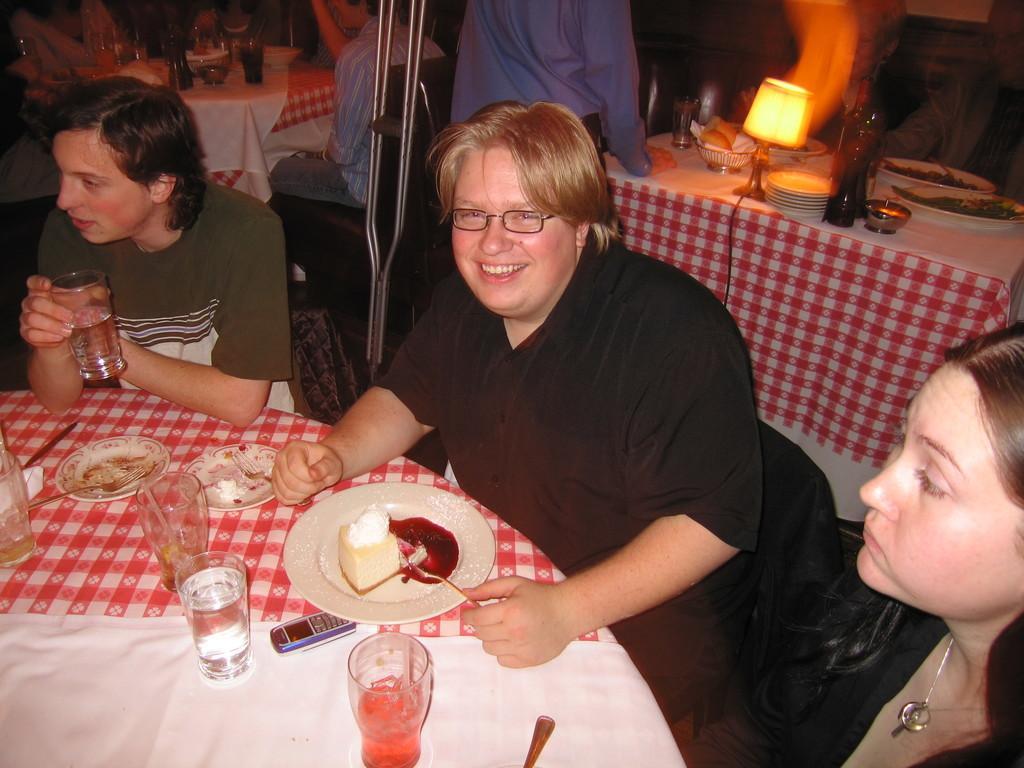How would you summarize this image in a sentence or two? As we can see in the image there are few people sitting and standing here and there is a table. On table there is a lamp, plate, cake peace, glasses and fork. 